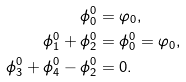<formula> <loc_0><loc_0><loc_500><loc_500>\phi _ { 0 } ^ { 0 } & = \varphi _ { 0 } , \\ \phi _ { 1 } ^ { 0 } + \phi _ { 2 } ^ { 0 } & = \phi _ { 0 } ^ { 0 } = \varphi _ { 0 } , \\ \phi _ { 3 } ^ { 0 } + \phi _ { 4 } ^ { 0 } - \phi _ { 2 } ^ { 0 } & = 0 .</formula> 